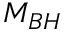Convert formula to latex. <formula><loc_0><loc_0><loc_500><loc_500>M _ { B H }</formula> 